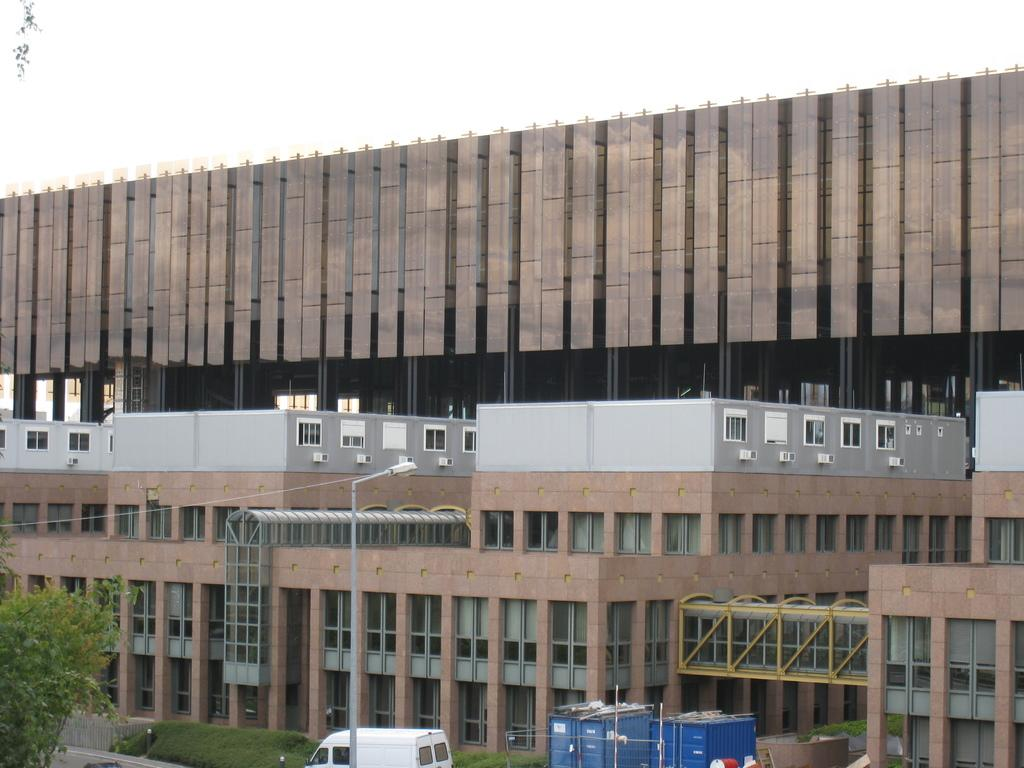What type of structure is visible in the image? There is a building in the image. Can you describe the color of the building? The building is brown and white in color. What can be seen in the foreground of the image? There are trees, vehicles, containers, and lights in the foreground of the image. Is there any blood visible on the table in the image? There is no table present in the image, and therefore no blood can be observed. 